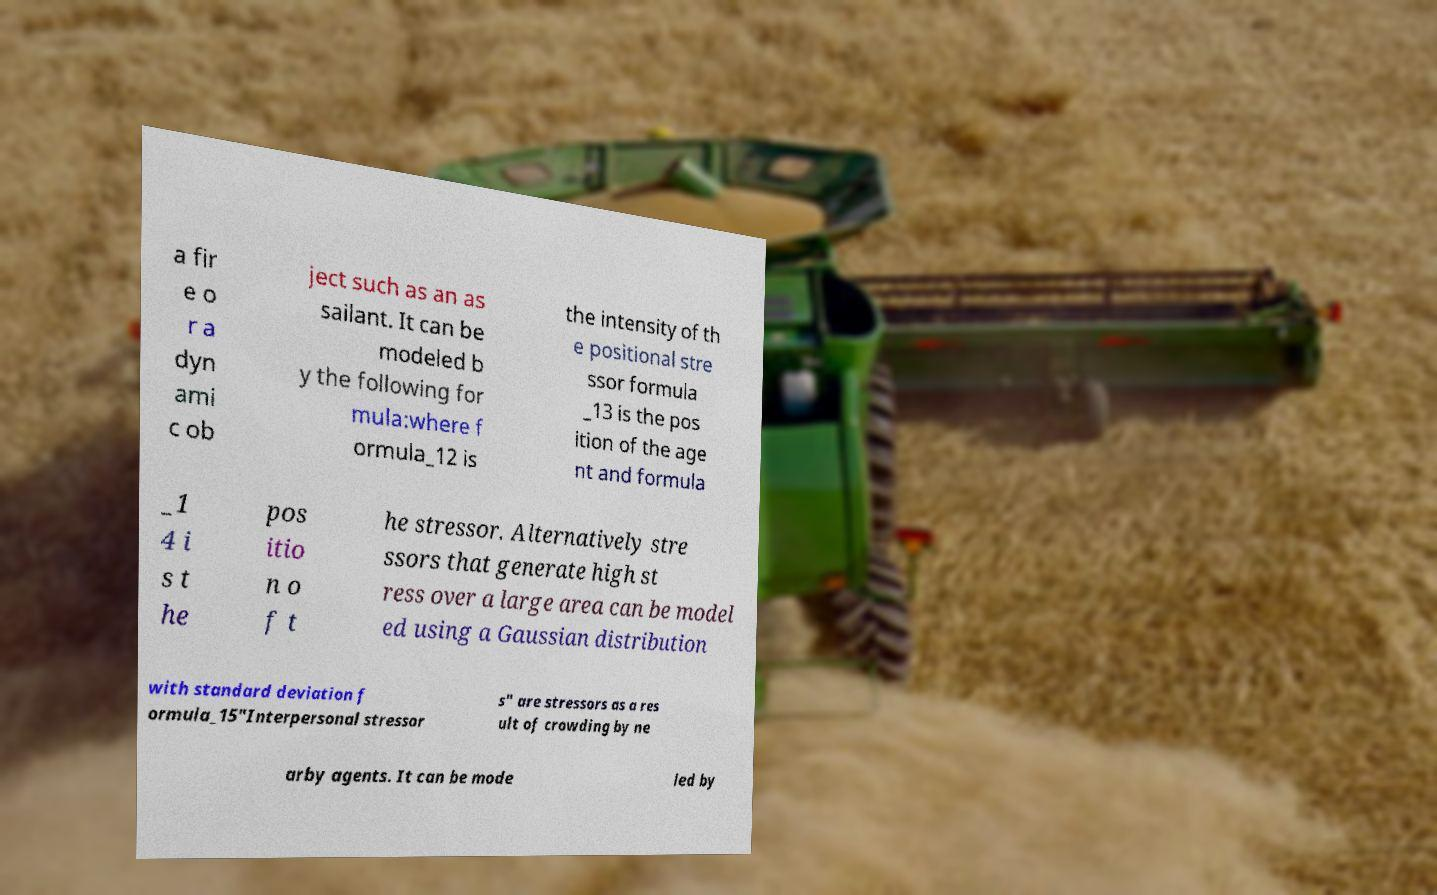Please read and relay the text visible in this image. What does it say? a fir e o r a dyn ami c ob ject such as an as sailant. It can be modeled b y the following for mula:where f ormula_12 is the intensity of th e positional stre ssor formula _13 is the pos ition of the age nt and formula _1 4 i s t he pos itio n o f t he stressor. Alternatively stre ssors that generate high st ress over a large area can be model ed using a Gaussian distribution with standard deviation f ormula_15"Interpersonal stressor s" are stressors as a res ult of crowding by ne arby agents. It can be mode led by 